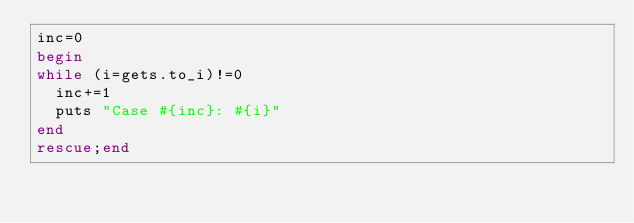Convert code to text. <code><loc_0><loc_0><loc_500><loc_500><_Ruby_>inc=0
begin
while (i=gets.to_i)!=0
  inc+=1
  puts "Case #{inc}: #{i}"
end
rescue;end
</code> 